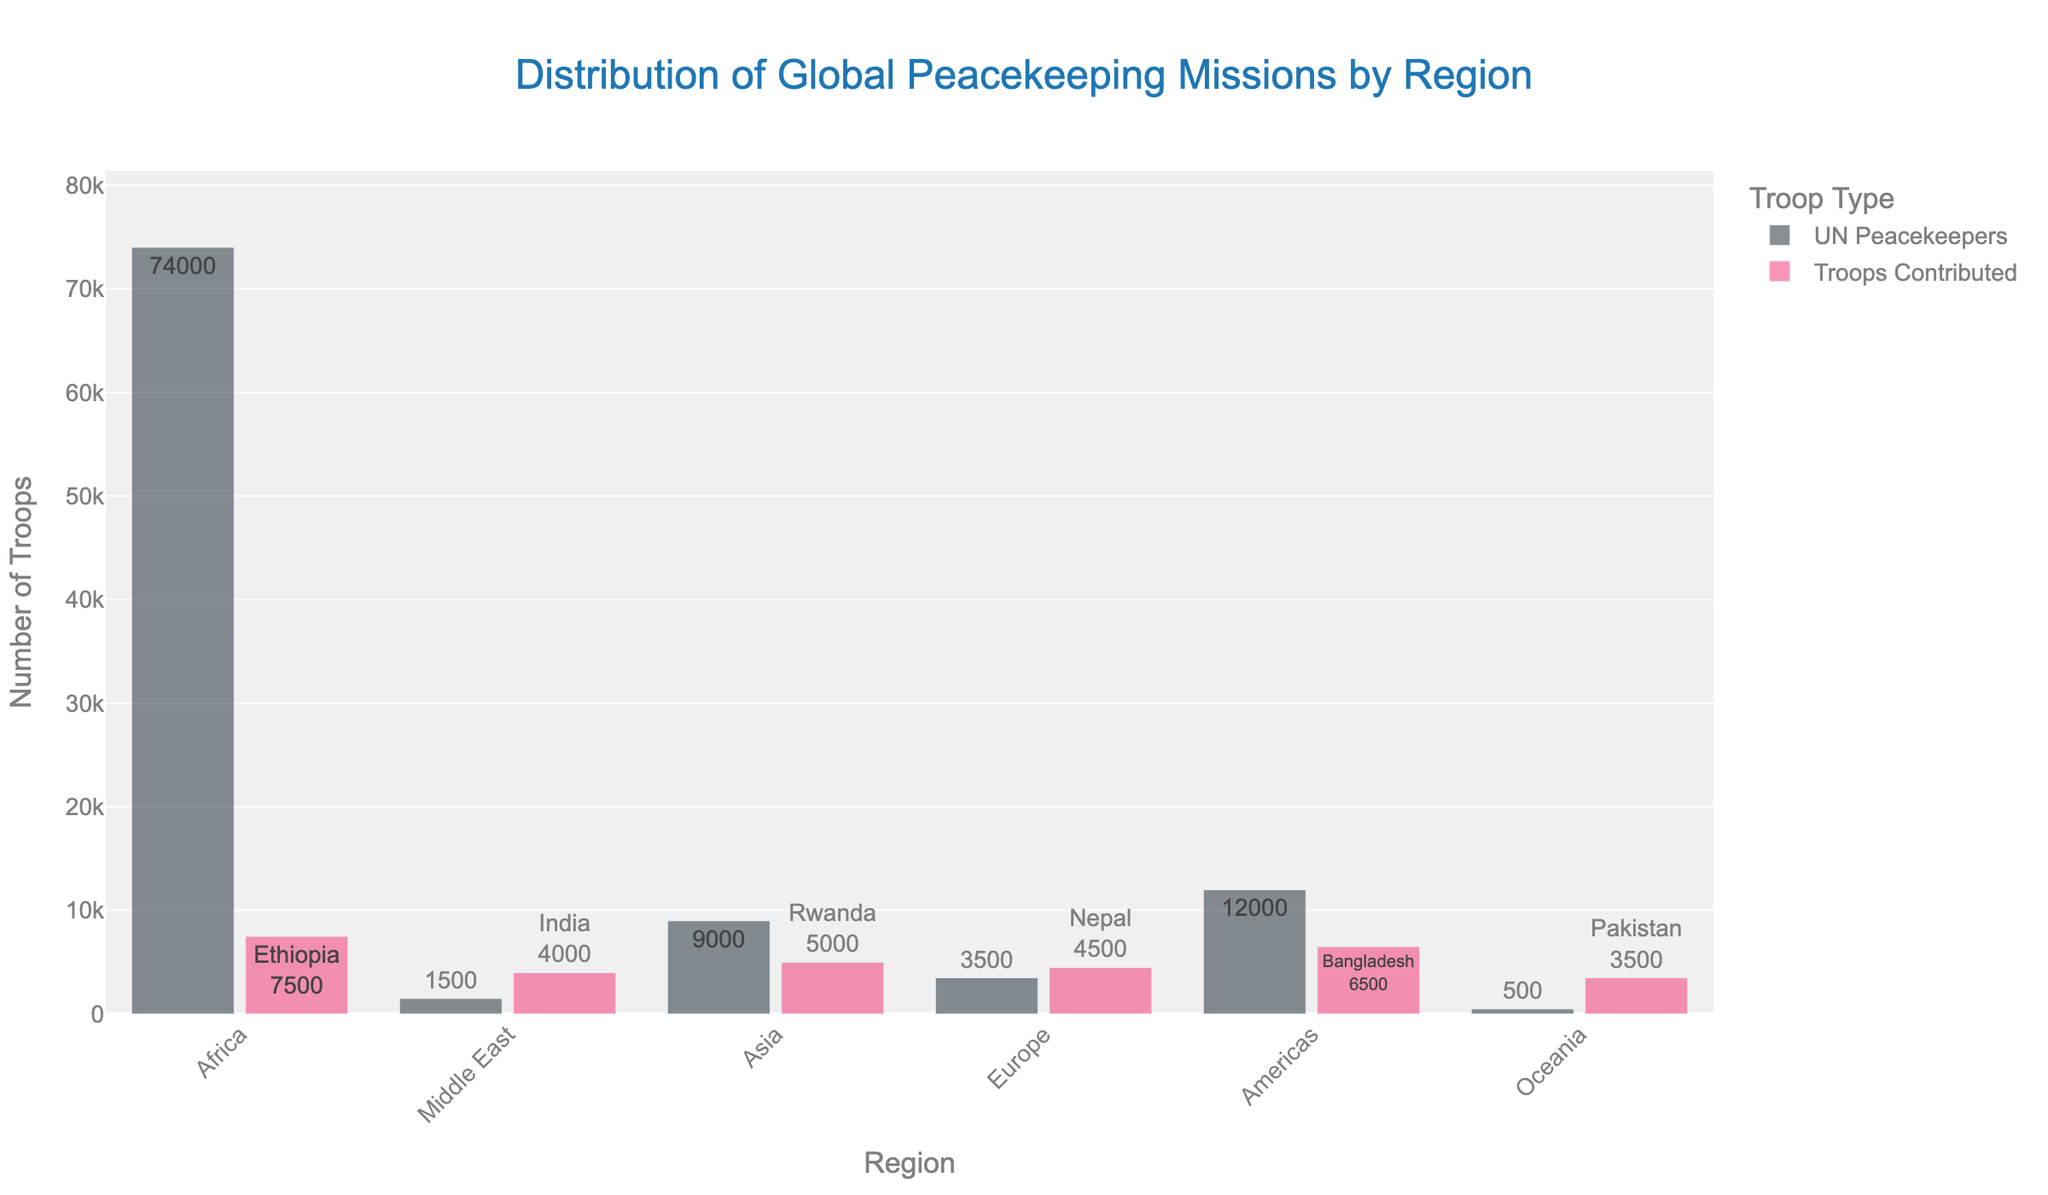Which region has the highest number of UN peacekeepers? Observe the height of the bars representing UN peacekeepers. The region with the tallest bar has the highest number. Africa has the tallest bar for UN Peacekeepers.
Answer: Africa Which region's top troop-contributing country provided the most troops? Look at the text labels on the bars for Troops Contributed for each region. The label with the highest number indicates the region. Ethiopia in Africa with 7500 troops contributed the most.
Answer: Africa How do the number of UN peacekeepers and troops contributed in Europe compare? Compare the heights of the two bars (UN Peacekeepers and Troops Contributed) for Europe. The UN Peacekeepers bar is taller, showing more peacekeepers (3500), while the Troops Contributed bar shows 1000 troops.
Answer: More UN Peacekeepers than troops contributed How many troops in total were contributed by the top troop-contributing countries across all regions? Sum the individual troop numbers from the text labels on the Troops Contributed bars for all regions: 7500 + 6500 + 5000 + 4500 + 4000 + 3500 + 3000 + 2800 + 2500 + 2200 + 2000 + 1800 + 1600 + 1400 + 1200 + 1000 + 800 + 600 = 57300.
Answer: 57300 What is the difference in the number of UN peacekeepers between Africa and the Americas? Subtract the height of the Americas' UN Peacekeepers bar from the height of the Africa's UN Peacekeepers bar: 74000 - 1500 = 72500.
Answer: 72500 Which region has the smallest number of UN peacekeepers and which country contributed the least troops in that region? Identify the region with the shortest UN Peacekeepers bar, which is Oceania with 500 peacekeepers. Then, find the corresponding Troops Contributed bar and its label, which shows Fiji with 600 troops.
Answer: Oceania and Fiji How do troop contributions from top-contributing countries in Asia compare against those in the Middle East? Sum the troop numbers from the text labels for Asia and the Middle East: Asia (5000 + 2500 + 1200) = 8700, Middle East (6500 + 2800 + 1400) = 10700. Compare the totals; the Middle East has more contributions.
Answer: Middle East has more troops What's the average number of troops contributed by the top troop-contributing countries in the Americas and Oceania? Calculate the average by summing the troops from the Americas and Oceania and divide by the total number of countries: (4000 + 2000 + 800 + 3500 + 1800 + 600)/6 = 12700/6 ≈ 2117.
Answer: 2117 